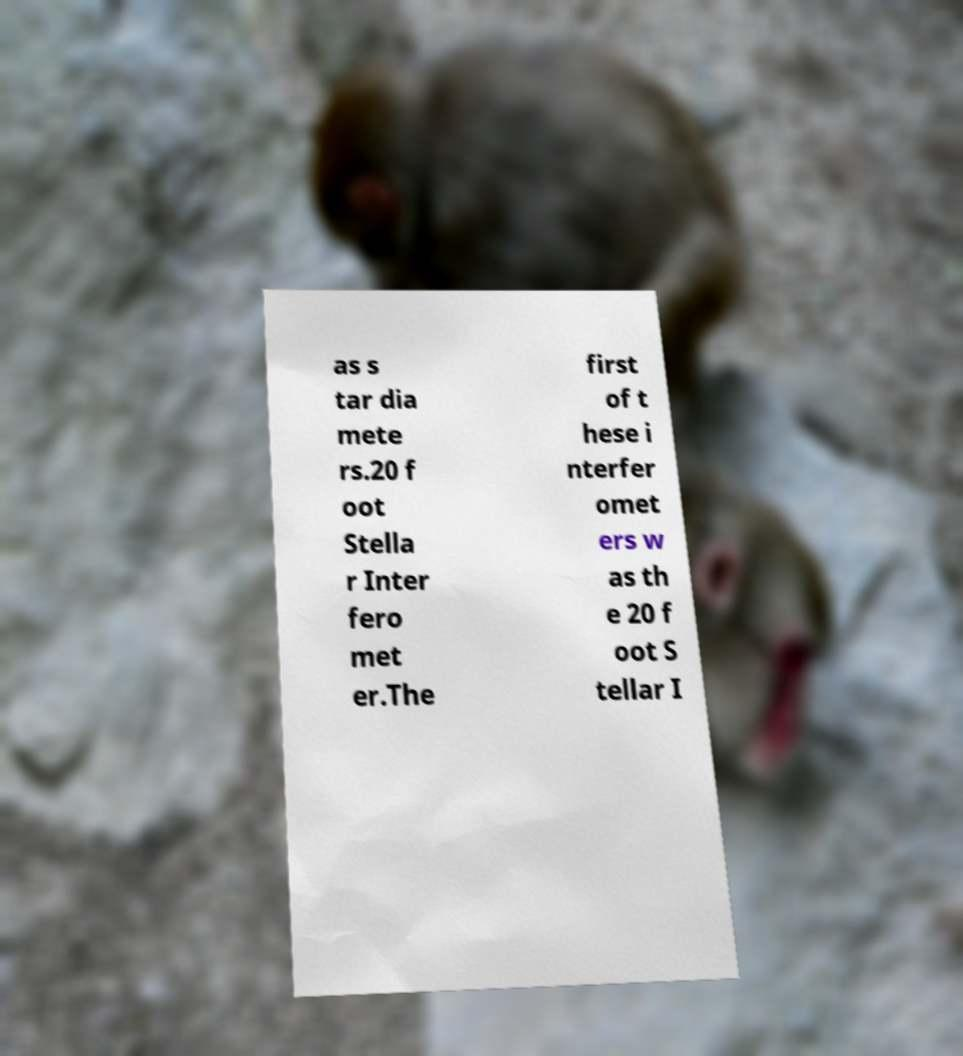What messages or text are displayed in this image? I need them in a readable, typed format. as s tar dia mete rs.20 f oot Stella r Inter fero met er.The first of t hese i nterfer omet ers w as th e 20 f oot S tellar I 